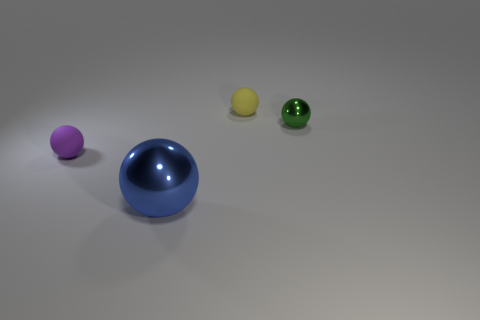Subtract all tiny spheres. How many spheres are left? 1 Subtract 1 spheres. How many spheres are left? 3 Subtract all blue balls. How many balls are left? 3 Add 4 green metal things. How many objects exist? 8 Subtract all red balls. Subtract all brown cubes. How many balls are left? 4 Subtract 0 brown cylinders. How many objects are left? 4 Subtract all large brown cylinders. Subtract all yellow rubber objects. How many objects are left? 3 Add 4 small purple spheres. How many small purple spheres are left? 5 Add 3 small purple matte balls. How many small purple matte balls exist? 4 